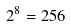Convert formula to latex. <formula><loc_0><loc_0><loc_500><loc_500>2 ^ { 8 } = 2 5 6</formula> 